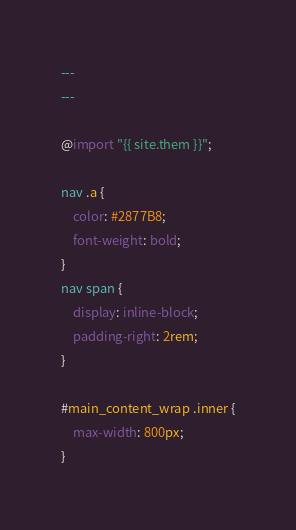Convert code to text. <code><loc_0><loc_0><loc_500><loc_500><_CSS_>---
---

@import "{{ site.them }}";

nav .a {
    color: #2877B8;
    font-weight: bold;
}
nav span {
    display: inline-block;
    padding-right: 2rem;
}

#main_content_wrap .inner {
	max-width: 800px;
}
</code> 